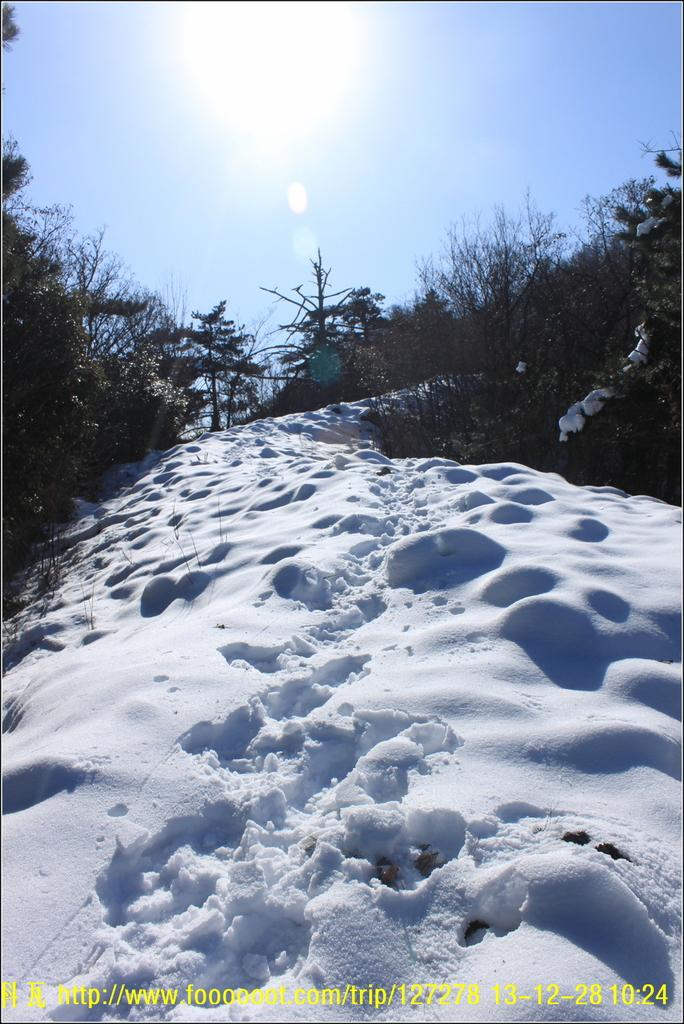What is the predominant weather condition in the image? There is snow in the image, indicating a cold and wintry condition. What type of vegetation can be seen in the image? There are trees and plants in the image. What is visible in the background of the image? The sky is visible in the background of the image. Can you describe any additional features of the image? There is a watermark at the bottom of the image. What type of bomb is depicted in the image? There is no bomb present in the image; it features snow, trees, plants, sky, and a watermark. Is there a crown visible in the image? There is no crown present in the image. 